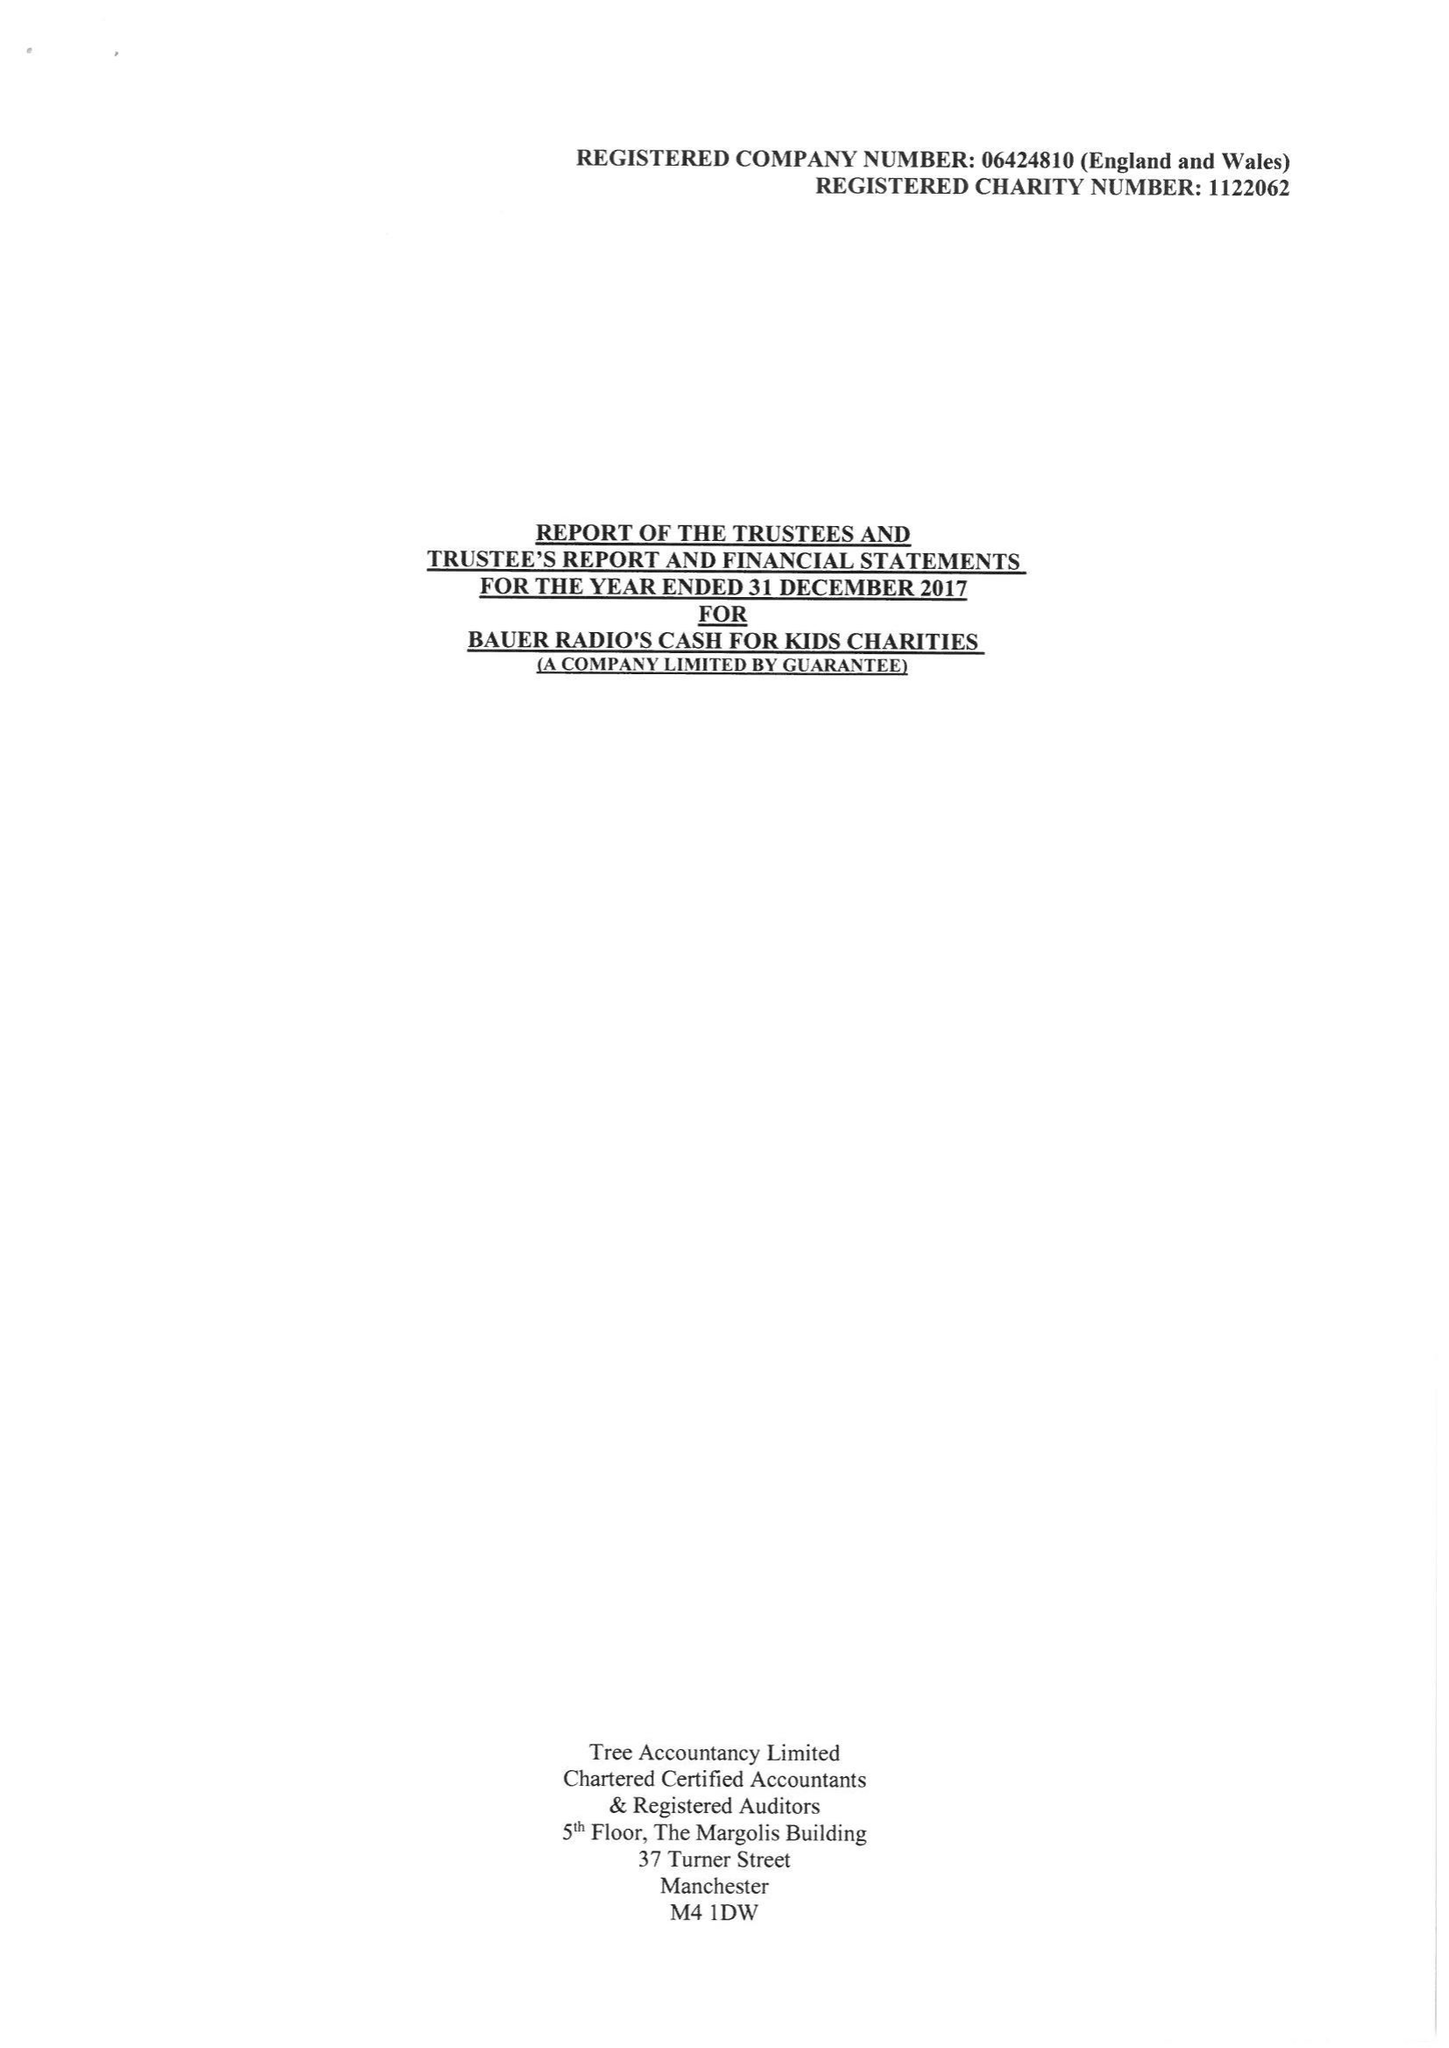What is the value for the spending_annually_in_british_pounds?
Answer the question using a single word or phrase. 16866909.00 